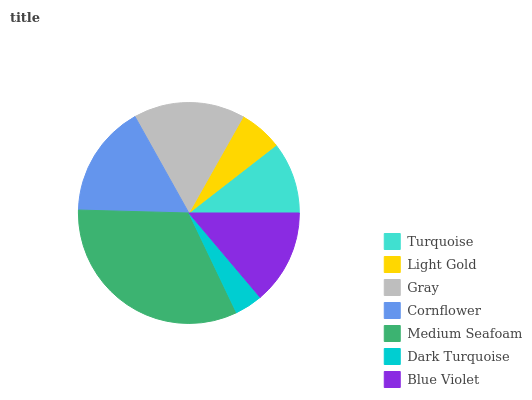Is Dark Turquoise the minimum?
Answer yes or no. Yes. Is Medium Seafoam the maximum?
Answer yes or no. Yes. Is Light Gold the minimum?
Answer yes or no. No. Is Light Gold the maximum?
Answer yes or no. No. Is Turquoise greater than Light Gold?
Answer yes or no. Yes. Is Light Gold less than Turquoise?
Answer yes or no. Yes. Is Light Gold greater than Turquoise?
Answer yes or no. No. Is Turquoise less than Light Gold?
Answer yes or no. No. Is Blue Violet the high median?
Answer yes or no. Yes. Is Blue Violet the low median?
Answer yes or no. Yes. Is Medium Seafoam the high median?
Answer yes or no. No. Is Light Gold the low median?
Answer yes or no. No. 